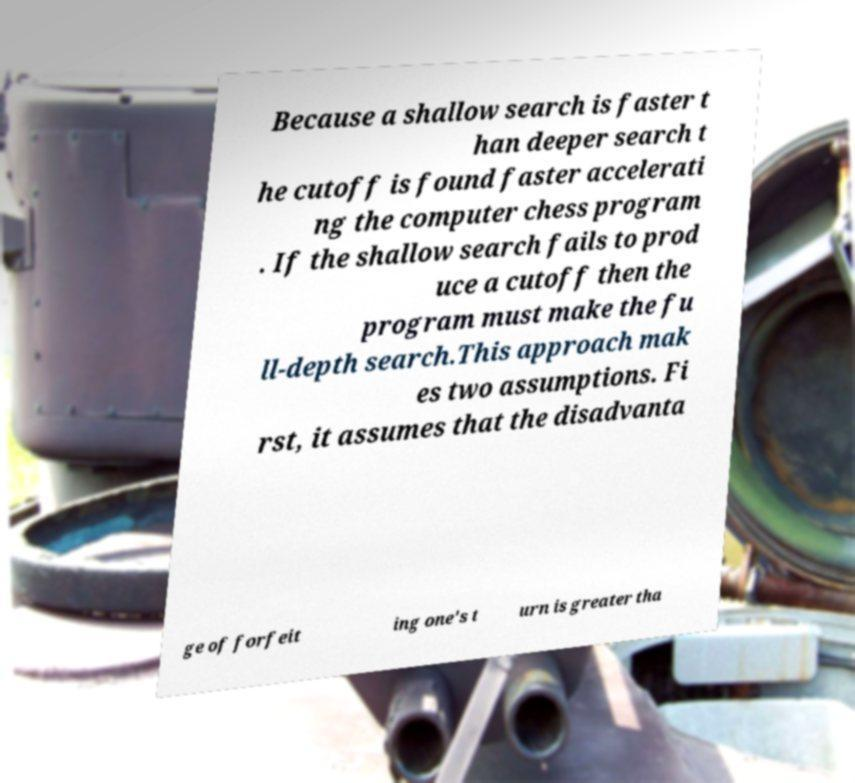What messages or text are displayed in this image? I need them in a readable, typed format. Because a shallow search is faster t han deeper search t he cutoff is found faster accelerati ng the computer chess program . If the shallow search fails to prod uce a cutoff then the program must make the fu ll-depth search.This approach mak es two assumptions. Fi rst, it assumes that the disadvanta ge of forfeit ing one's t urn is greater tha 